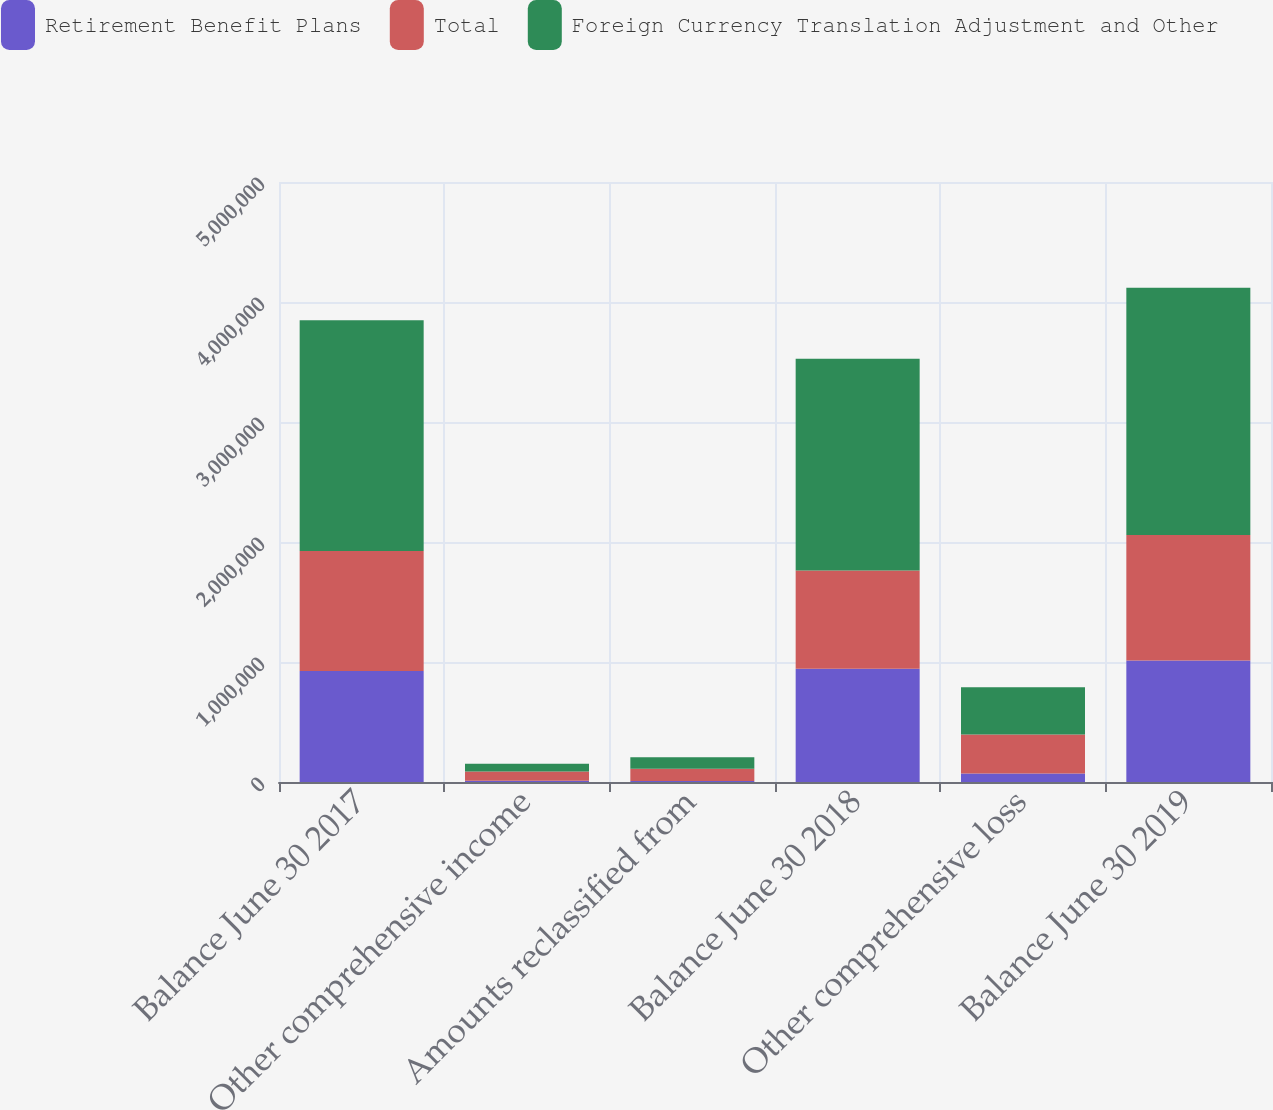Convert chart to OTSL. <chart><loc_0><loc_0><loc_500><loc_500><stacked_bar_chart><ecel><fcel>Balance June 30 2017<fcel>Other comprehensive income<fcel>Amounts reclassified from<fcel>Balance June 30 2018<fcel>Other comprehensive loss<fcel>Balance June 30 2019<nl><fcel>Retirement Benefit Plans<fcel>925342<fcel>10141<fcel>7994<fcel>943477<fcel>70023<fcel>1.01166e+06<nl><fcel>Total<fcel>998862<fcel>76417<fcel>102836<fcel>819609<fcel>325213<fcel>1.04739e+06<nl><fcel>Foreign Currency Translation Adjustment and Other<fcel>1.9242e+06<fcel>66276<fcel>94842<fcel>1.76309e+06<fcel>395236<fcel>2.05905e+06<nl></chart> 